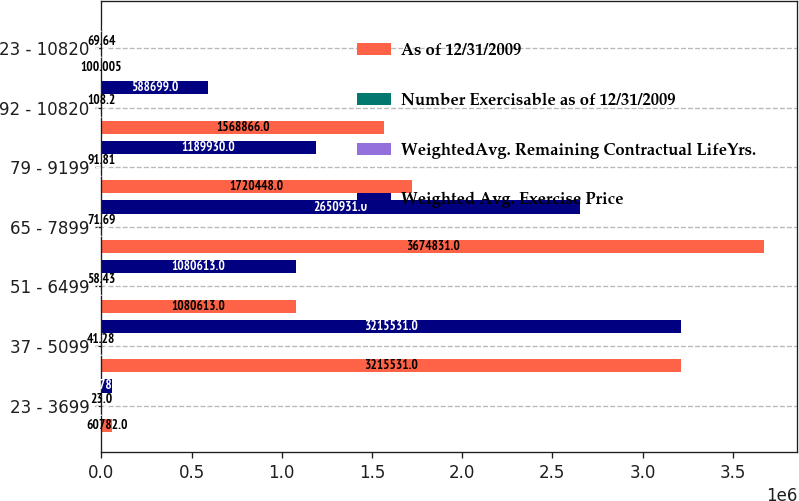<chart> <loc_0><loc_0><loc_500><loc_500><stacked_bar_chart><ecel><fcel>23 - 3699<fcel>37 - 5099<fcel>51 - 6499<fcel>65 - 7899<fcel>79 - 9199<fcel>92 - 10820<fcel>23 - 10820<nl><fcel>As of 12/31/2009<fcel>60782<fcel>3.21553e+06<fcel>1.08061e+06<fcel>3.67483e+06<fcel>1.72045e+06<fcel>1.56887e+06<fcel>100.005<nl><fcel>Number Exercisable as of 12/31/2009<fcel>0.9<fcel>2.1<fcel>4.1<fcel>6.5<fcel>7.1<fcel>8.1<fcel>5.3<nl><fcel>WeightedAvg. Remaining Contractual LifeYrs.<fcel>23<fcel>41.28<fcel>58.43<fcel>71.69<fcel>91.81<fcel>108.2<fcel>69.64<nl><fcel>Weighted Avg. Exercise Price<fcel>60782<fcel>3.21553e+06<fcel>1.08061e+06<fcel>2.65093e+06<fcel>1.18993e+06<fcel>588699<fcel>100.005<nl></chart> 